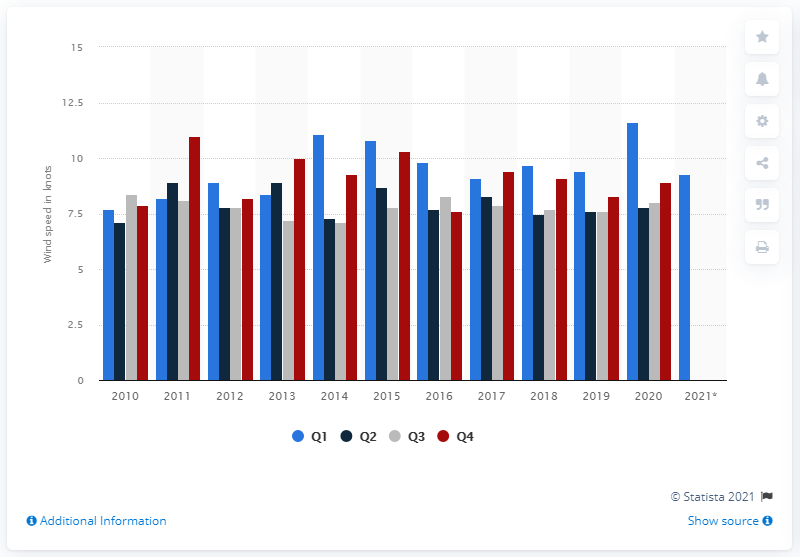Identify some key points in this picture. The year with the greatest wind speeds outside the winter months was 2010. In 2015, the year with the highest wind speed in the UK was recorded. 